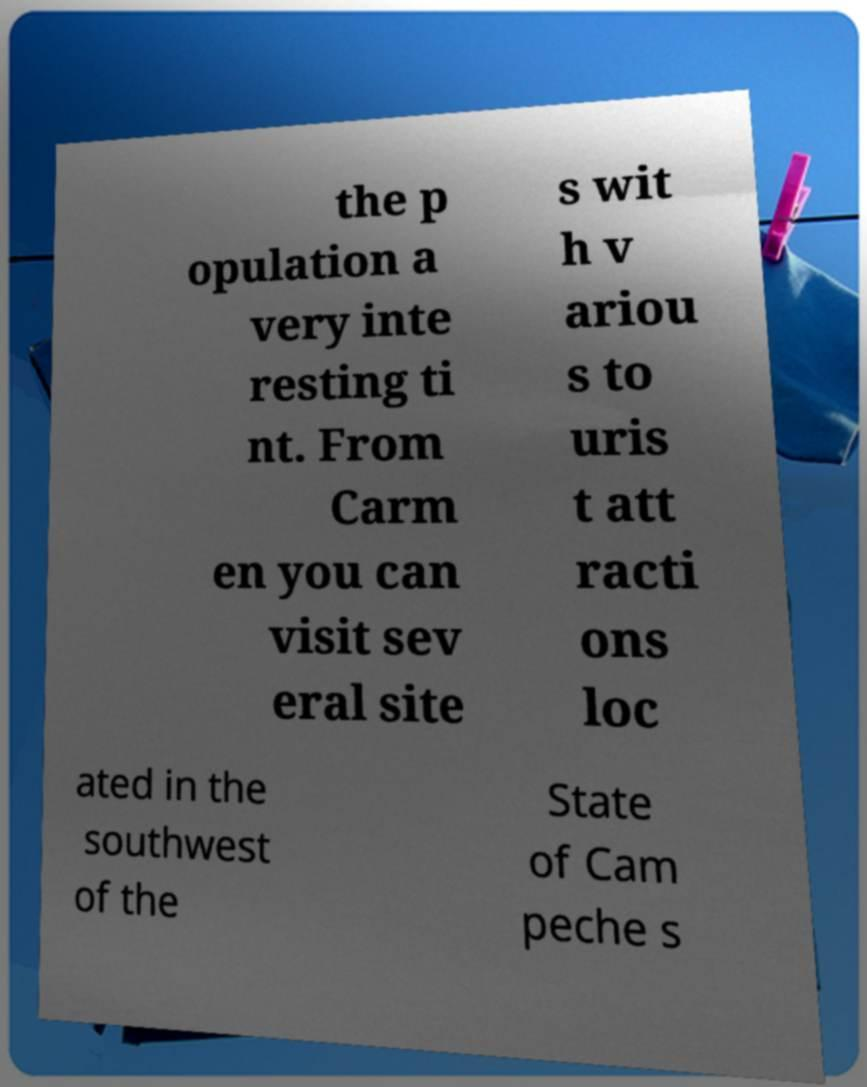Can you accurately transcribe the text from the provided image for me? the p opulation a very inte resting ti nt. From Carm en you can visit sev eral site s wit h v ariou s to uris t att racti ons loc ated in the southwest of the State of Cam peche s 